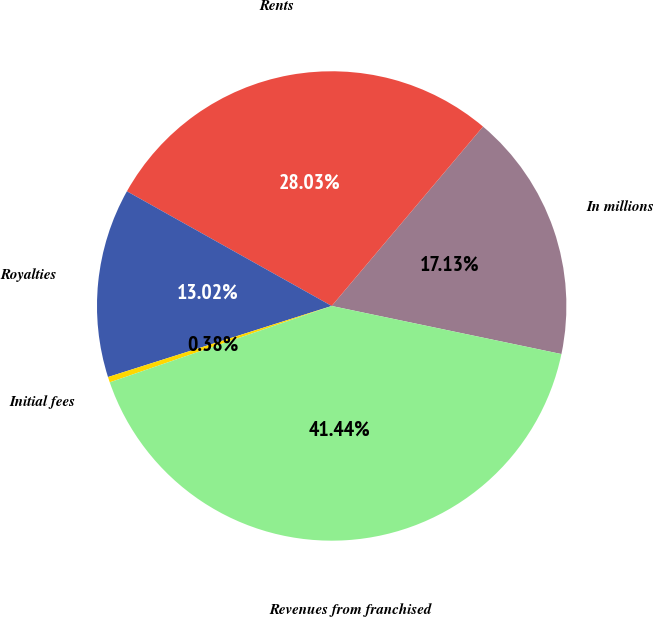Convert chart to OTSL. <chart><loc_0><loc_0><loc_500><loc_500><pie_chart><fcel>In millions<fcel>Rents<fcel>Royalties<fcel>Initial fees<fcel>Revenues from franchised<nl><fcel>17.13%<fcel>28.03%<fcel>13.02%<fcel>0.38%<fcel>41.44%<nl></chart> 